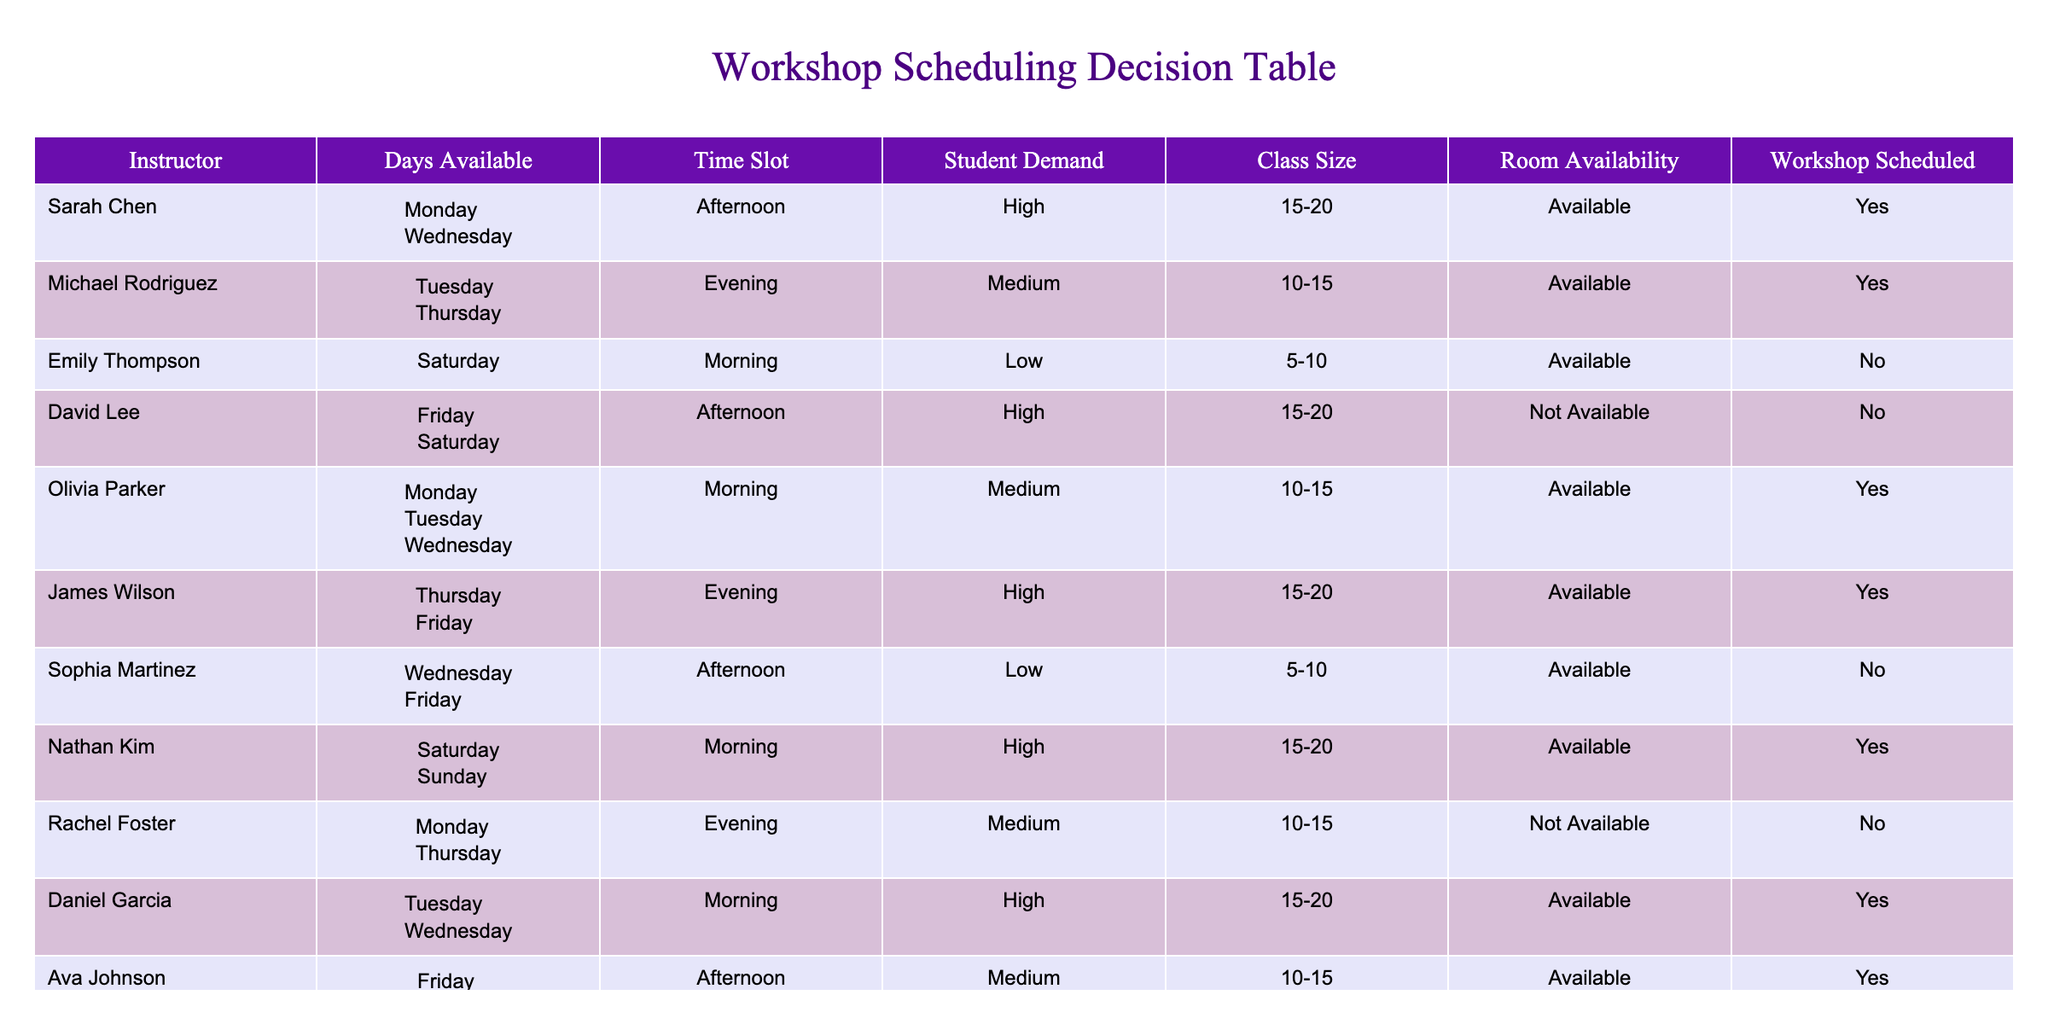What is the maximum number of students that can attend a workshop with high student demand? In the table, workshops with high student demand have class sizes ranging from 15 to 20 students. The workshops listed under high demand are taught by Sarah Chen, David Lee, James Wilson, Nathan Kim, Daniel Garcia, and Zoe Anderson. Therefore, the maximum class size in this category is 20 students.
Answer: 20 Which instructors are available on Friday? According to the table, the instructors available on Friday are James Wilson and Ava Johnson, as both have "Available" marked under Room Availability for that day.
Answer: James Wilson, Ava Johnson How many workshops have been scheduled despite low student demand? Low student demand is indicated in the table for Emily Thompson and Sophia Martinez, but both workshops are marked as "No" under Workshop Scheduled. Therefore, there are no workshops scheduled with low student demand.
Answer: 0 Does Olivia Parker have any workshops scheduled on Monday? Yes, the table shows that Olivia Parker is available on Monday and has a workshop scheduled.
Answer: Yes What is the total number of workshops scheduled for instructors available on weekends? The instructors available on weekends are Nathan Kim and Emily Thompson. Nathan Kim has a workshop scheduled, but Emily Thompson does not. Thus, only 1 workshop is scheduled for the Saturday instructor.
Answer: 1 Which time slots have high student demand workshops that are scheduled? The time slots with high student demand workshops that are scheduled are the Afternoon for Sarah Chen, and the Evening for James Wilson, both of which have been listed as "Yes" under Workshop Scheduled.
Answer: Afternoon, Evening Are any instructors available both Tuesday and Wednesday? Yes, both Daniel Garcia and Michael Rodriguez are marked as available on Tuesday and Wednesday.
Answer: Yes What percentage of scheduled workshops are taught by female instructors? The scheduled workshops are taught by Sarah Chen, Emily Thompson, Olivia Parker, and Zoe Anderson. There are 4 scheduled workshops, and out of these, 3 are taught by female instructors (Sarah Chen, Olivia Parker, Zoe Anderson). The percentage is (3/4) * 100 = 75%.
Answer: 75% How many instructors are available in the evening on multiple days? In the table, Michael Rodriguez is available on Tuesday and Thursday evenings and Rachel Foster is available on Monday and Thursday evenings. Hence, two instructors are available in the evening on multiple days.
Answer: 2 